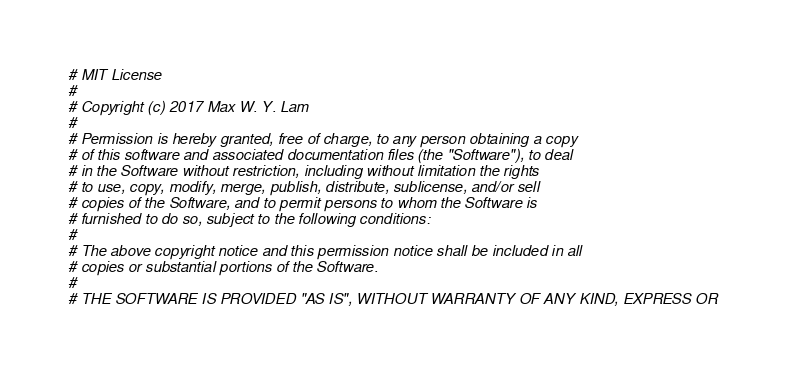<code> <loc_0><loc_0><loc_500><loc_500><_Python_># MIT License
# 
# Copyright (c) 2017 Max W. Y. Lam
# 
# Permission is hereby granted, free of charge, to any person obtaining a copy
# of this software and associated documentation files (the "Software"), to deal
# in the Software without restriction, including without limitation the rights
# to use, copy, modify, merge, publish, distribute, sublicense, and/or sell
# copies of the Software, and to permit persons to whom the Software is
# furnished to do so, subject to the following conditions:
# 
# The above copyright notice and this permission notice shall be included in all
# copies or substantial portions of the Software.
# 
# THE SOFTWARE IS PROVIDED "AS IS", WITHOUT WARRANTY OF ANY KIND, EXPRESS OR</code> 